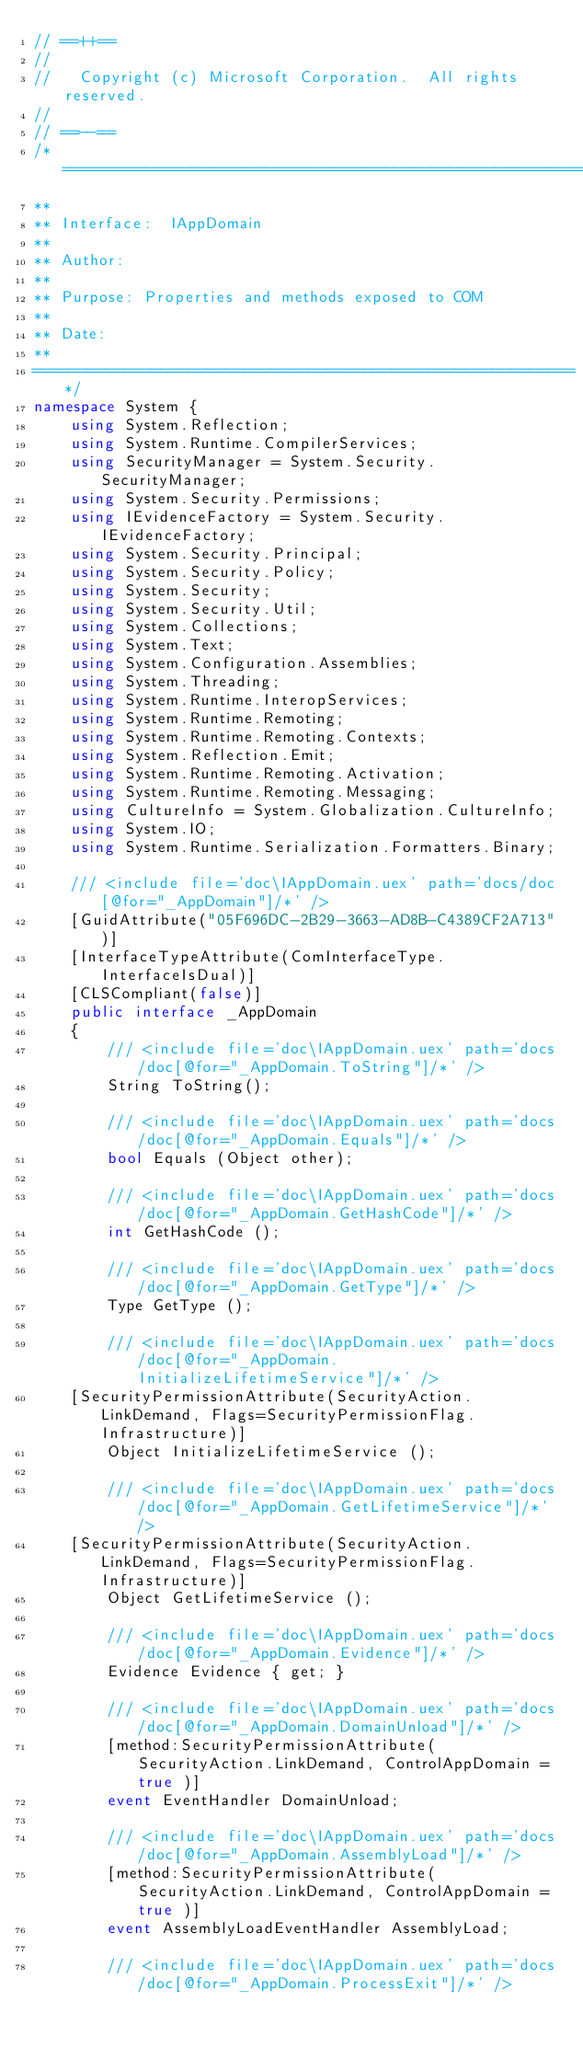Convert code to text. <code><loc_0><loc_0><loc_500><loc_500><_C#_>// ==++==
// 
//   Copyright (c) Microsoft Corporation.  All rights reserved.
// 
// ==--==
/*============================================================
**
** Interface:  IAppDomain
**
** Author: 
**
** Purpose: Properties and methods exposed to COM
**
** Date:  
** 
===========================================================*/
namespace System {
    using System.Reflection;
    using System.Runtime.CompilerServices;
    using SecurityManager = System.Security.SecurityManager;
    using System.Security.Permissions;
    using IEvidenceFactory = System.Security.IEvidenceFactory;
    using System.Security.Principal;
    using System.Security.Policy;
    using System.Security;
    using System.Security.Util;
    using System.Collections;
    using System.Text;
    using System.Configuration.Assemblies;
    using System.Threading;
    using System.Runtime.InteropServices;
    using System.Runtime.Remoting;   
    using System.Runtime.Remoting.Contexts;
    using System.Reflection.Emit;
    using System.Runtime.Remoting.Activation;
    using System.Runtime.Remoting.Messaging;
    using CultureInfo = System.Globalization.CultureInfo;
    using System.IO;
    using System.Runtime.Serialization.Formatters.Binary;

    /// <include file='doc\IAppDomain.uex' path='docs/doc[@for="_AppDomain"]/*' />
    [GuidAttribute("05F696DC-2B29-3663-AD8B-C4389CF2A713")]
    [InterfaceTypeAttribute(ComInterfaceType.InterfaceIsDual)]
    [CLSCompliant(false)]
    public interface _AppDomain
    {
        /// <include file='doc\IAppDomain.uex' path='docs/doc[@for="_AppDomain.ToString"]/*' />
        String ToString();

        /// <include file='doc\IAppDomain.uex' path='docs/doc[@for="_AppDomain.Equals"]/*' />
        bool Equals (Object other);

        /// <include file='doc\IAppDomain.uex' path='docs/doc[@for="_AppDomain.GetHashCode"]/*' />
        int GetHashCode ();

        /// <include file='doc\IAppDomain.uex' path='docs/doc[@for="_AppDomain.GetType"]/*' />
        Type GetType ();

        /// <include file='doc\IAppDomain.uex' path='docs/doc[@for="_AppDomain.InitializeLifetimeService"]/*' />
	[SecurityPermissionAttribute(SecurityAction.LinkDemand, Flags=SecurityPermissionFlag.Infrastructure)]	
        Object InitializeLifetimeService ();

        /// <include file='doc\IAppDomain.uex' path='docs/doc[@for="_AppDomain.GetLifetimeService"]/*' />
	[SecurityPermissionAttribute(SecurityAction.LinkDemand, Flags=SecurityPermissionFlag.Infrastructure)]	
        Object GetLifetimeService ();

        /// <include file='doc\IAppDomain.uex' path='docs/doc[@for="_AppDomain.Evidence"]/*' />
        Evidence Evidence { get; }

        /// <include file='doc\IAppDomain.uex' path='docs/doc[@for="_AppDomain.DomainUnload"]/*' />
        [method:SecurityPermissionAttribute( SecurityAction.LinkDemand, ControlAppDomain = true )]
        event EventHandler DomainUnload;

        /// <include file='doc\IAppDomain.uex' path='docs/doc[@for="_AppDomain.AssemblyLoad"]/*' />
        [method:SecurityPermissionAttribute( SecurityAction.LinkDemand, ControlAppDomain = true )]
        event AssemblyLoadEventHandler AssemblyLoad;

        /// <include file='doc\IAppDomain.uex' path='docs/doc[@for="_AppDomain.ProcessExit"]/*' /></code> 